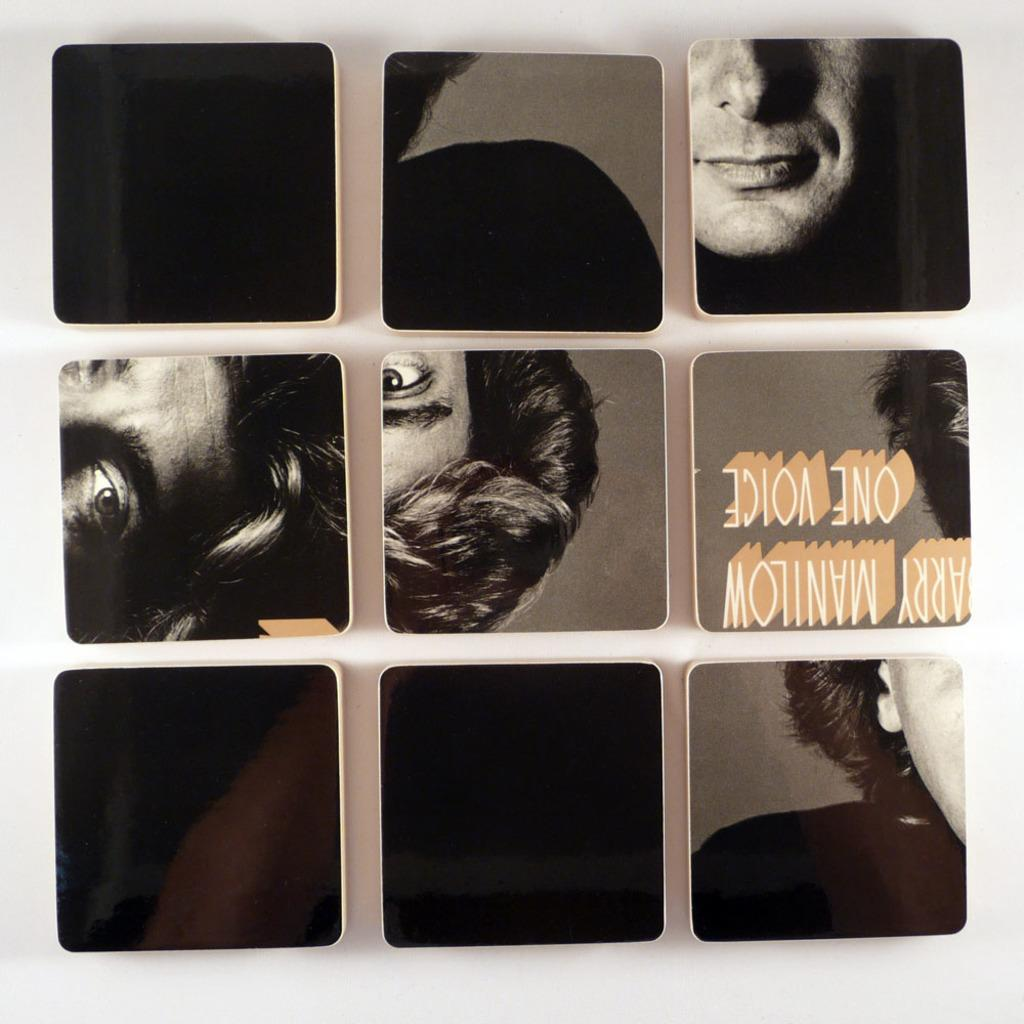What type of image is being described? The image is an edited photo. What can be seen in the edited photo? There is a person's face in the image. Are there any words or phrases in the image? Yes, there is text in the image. How far can the person's knee be seen in the image? There is no visible knee in the image; only the person's face is shown. 